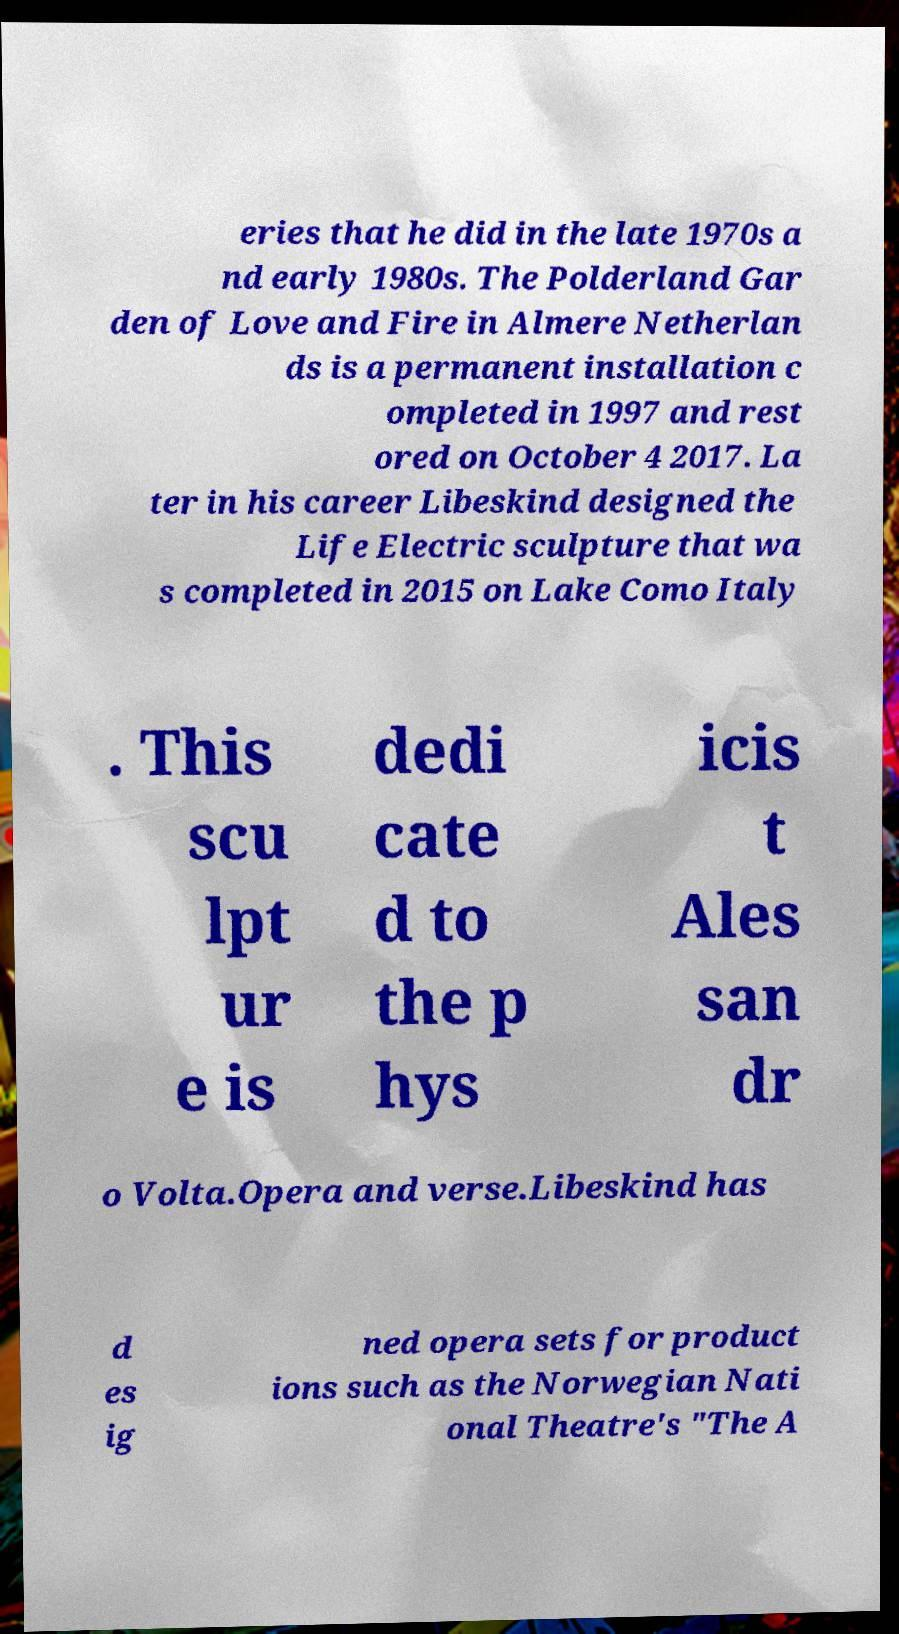For documentation purposes, I need the text within this image transcribed. Could you provide that? eries that he did in the late 1970s a nd early 1980s. The Polderland Gar den of Love and Fire in Almere Netherlan ds is a permanent installation c ompleted in 1997 and rest ored on October 4 2017. La ter in his career Libeskind designed the Life Electric sculpture that wa s completed in 2015 on Lake Como Italy . This scu lpt ur e is dedi cate d to the p hys icis t Ales san dr o Volta.Opera and verse.Libeskind has d es ig ned opera sets for product ions such as the Norwegian Nati onal Theatre's "The A 